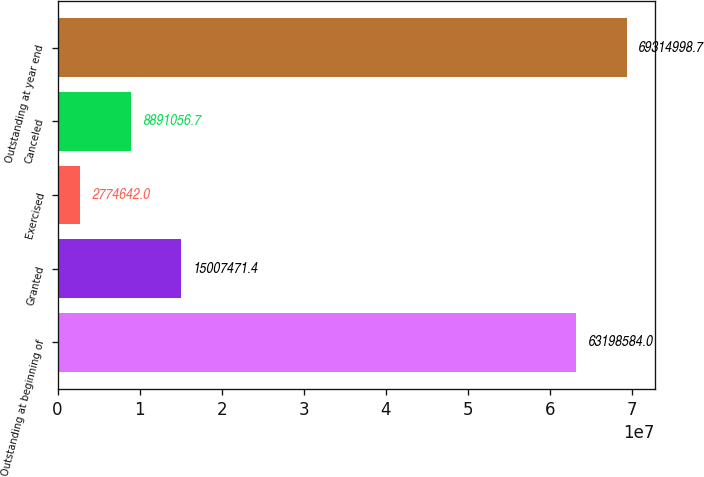<chart> <loc_0><loc_0><loc_500><loc_500><bar_chart><fcel>Outstanding at beginning of<fcel>Granted<fcel>Exercised<fcel>Canceled<fcel>Outstanding at year end<nl><fcel>6.31986e+07<fcel>1.50075e+07<fcel>2.77464e+06<fcel>8.89106e+06<fcel>6.9315e+07<nl></chart> 